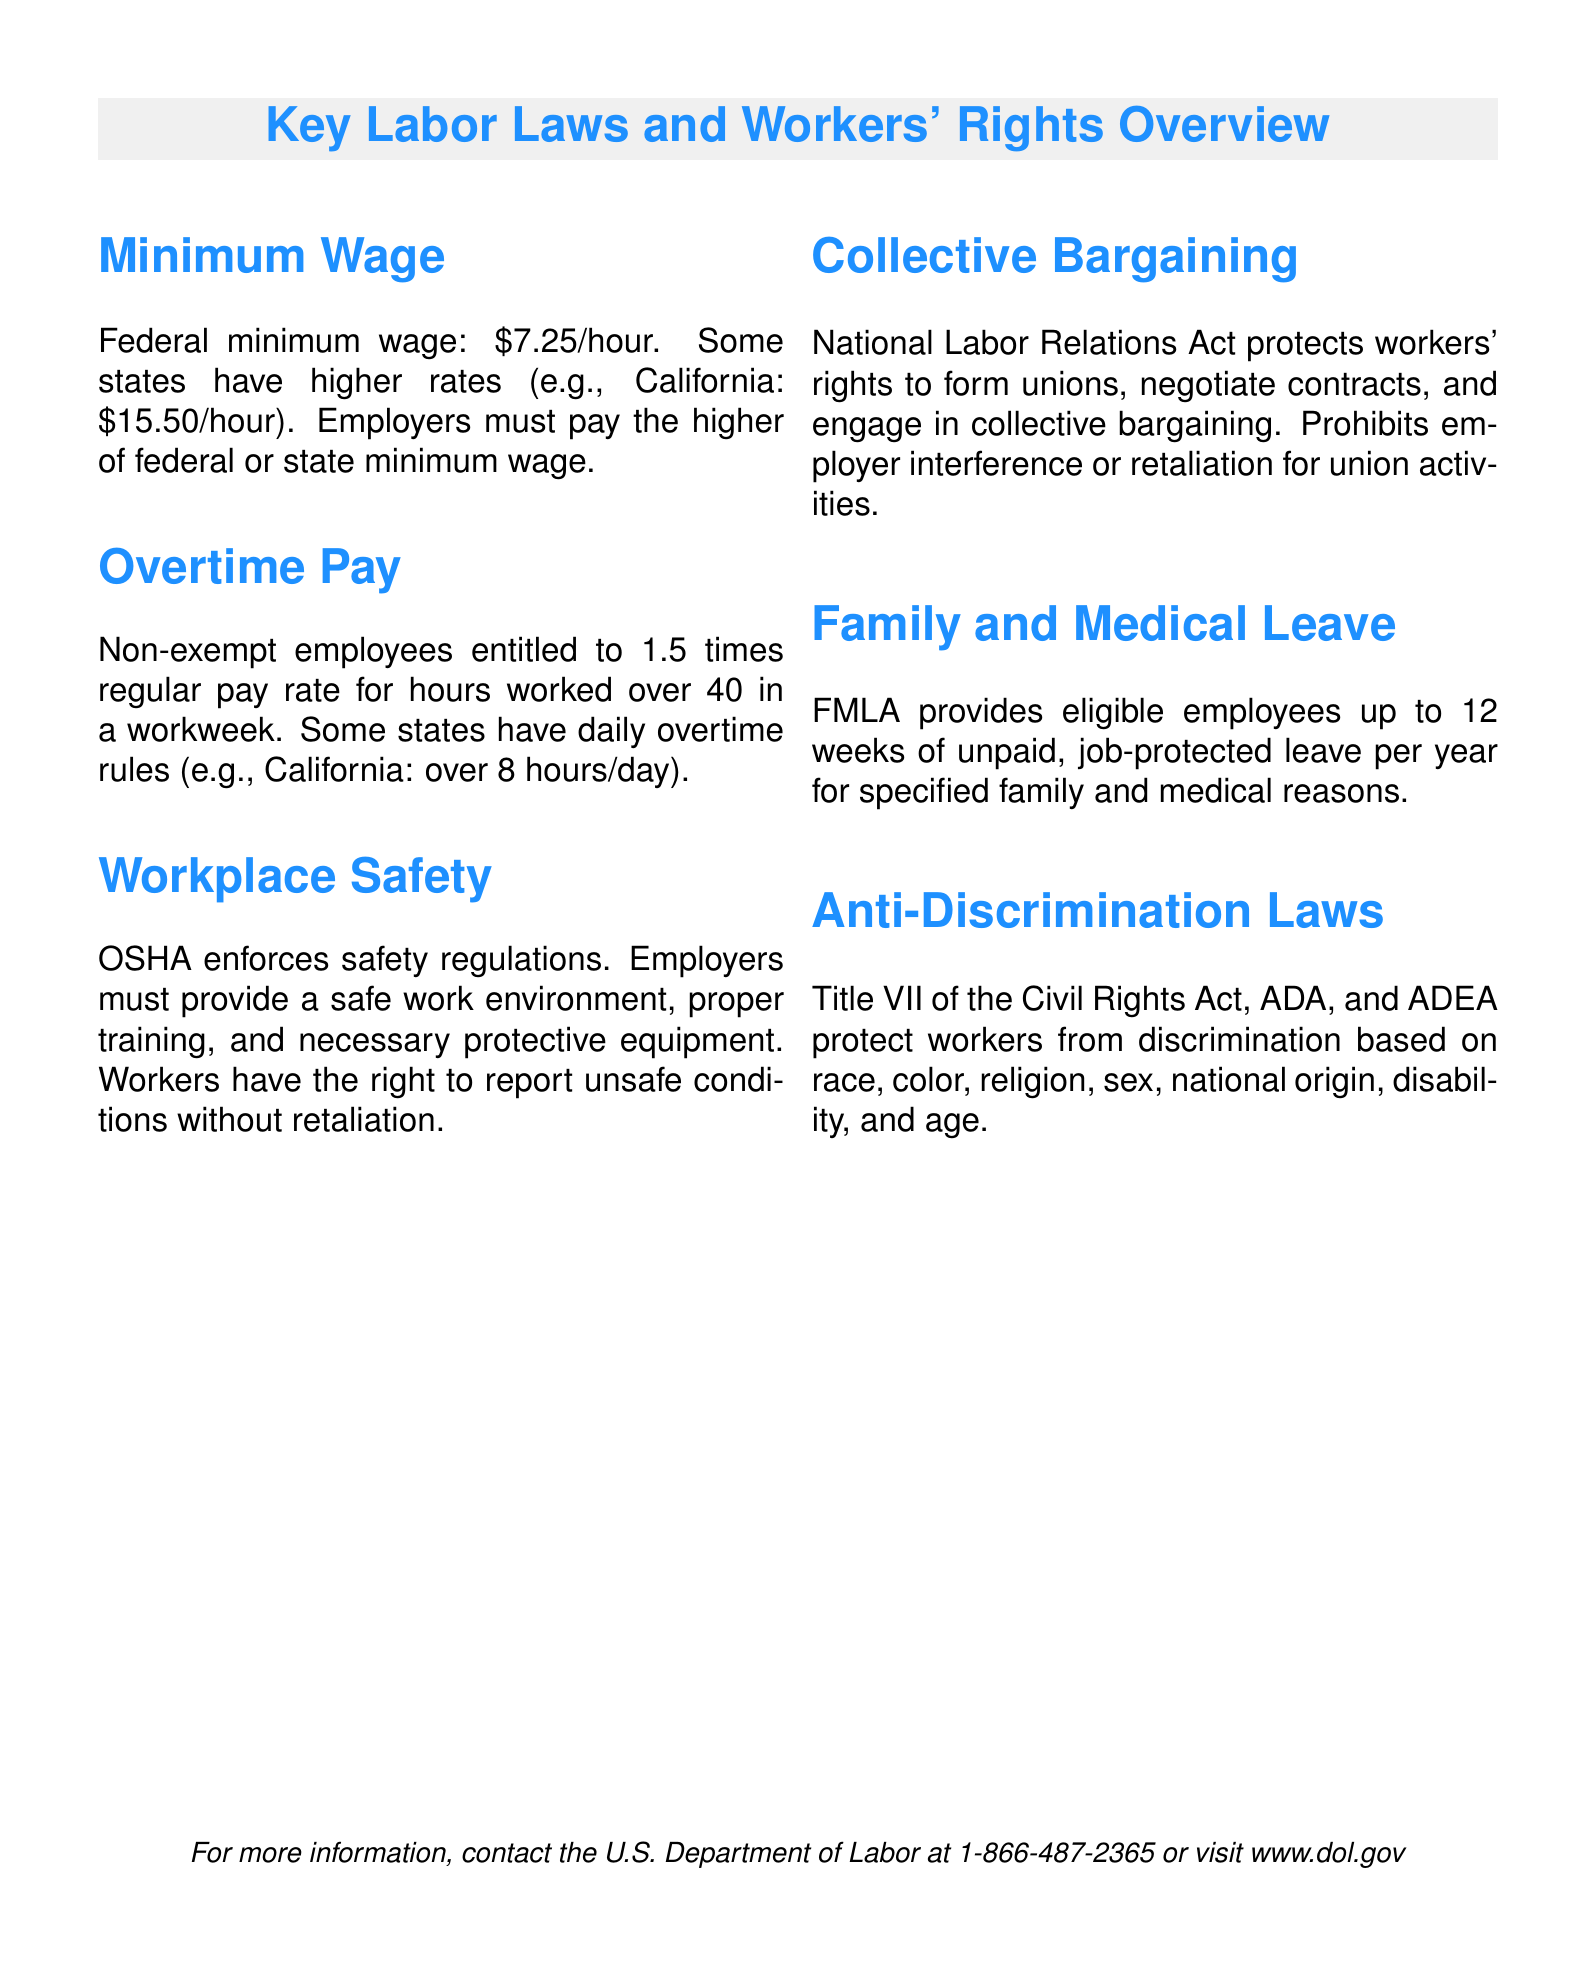What is the federal minimum wage? The federal minimum wage is stated in the document as \$7.25/hour.
Answer: \$7.25/hour What is California's minimum wage? The document specifies California's minimum wage as \$15.50/hour, which is a higher rate than federal.
Answer: \$15.50/hour What is the overtime pay rate for non-exempt employees? The document indicates that non-exempt employees are entitled to 1.5 times their regular pay rate for overtime.
Answer: 1.5 times regular pay What do OSHA regulations enforce? The document states that OSHA enforces safety regulations to ensure workplace safety.
Answer: Safety regulations What rights do workers have when reporting unsafe conditions? Workers have the right to report unsafe conditions without retaliation, as noted in the document.
Answer: Without retaliation What does the National Labor Relations Act protect? The document specifies that the National Labor Relations Act protects workers' rights to form unions and engage in collective bargaining.
Answer: Workers' rights to form unions How many weeks of unpaid leave does FMLA provide? The document states that FMLA provides up to 12 weeks of unpaid leave per year.
Answer: 12 weeks What types of discrimination are covered by anti-discrimination laws? The document lists race, color, religion, sex, national origin, disability, and age as forms of discrimination covered.
Answer: Race, color, religion, sex, national origin, disability, age What agency can be contacted for more information? The document advises contacting the U.S. Department of Labor for more information.
Answer: U.S. Department of Labor 